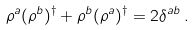Convert formula to latex. <formula><loc_0><loc_0><loc_500><loc_500>\rho ^ { a } ( \rho ^ { b } ) ^ { \dagger } + \rho ^ { b } ( \rho ^ { a } ) ^ { \dagger } = 2 \delta ^ { a b } \, .</formula> 